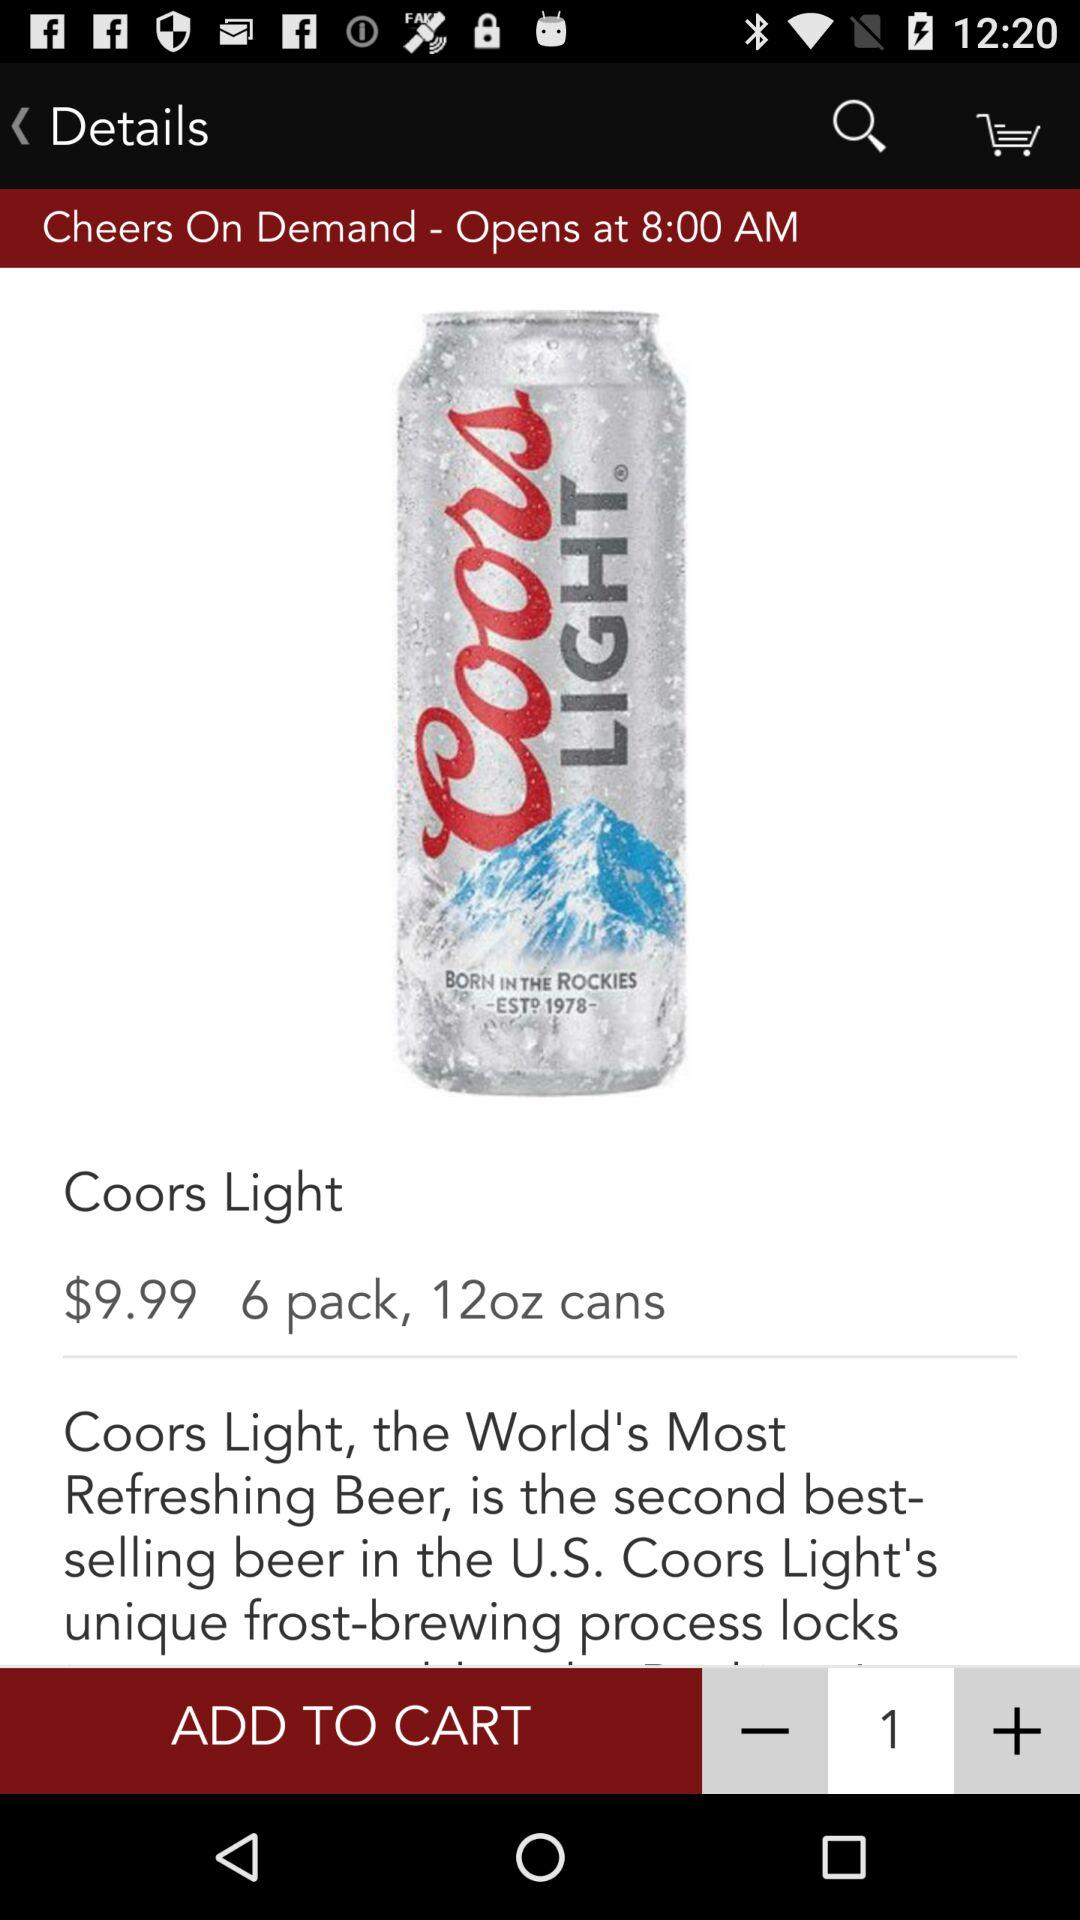At what time "Cheers On Demand" will open? "Cheers On Demand" will open at 8 a.m. 